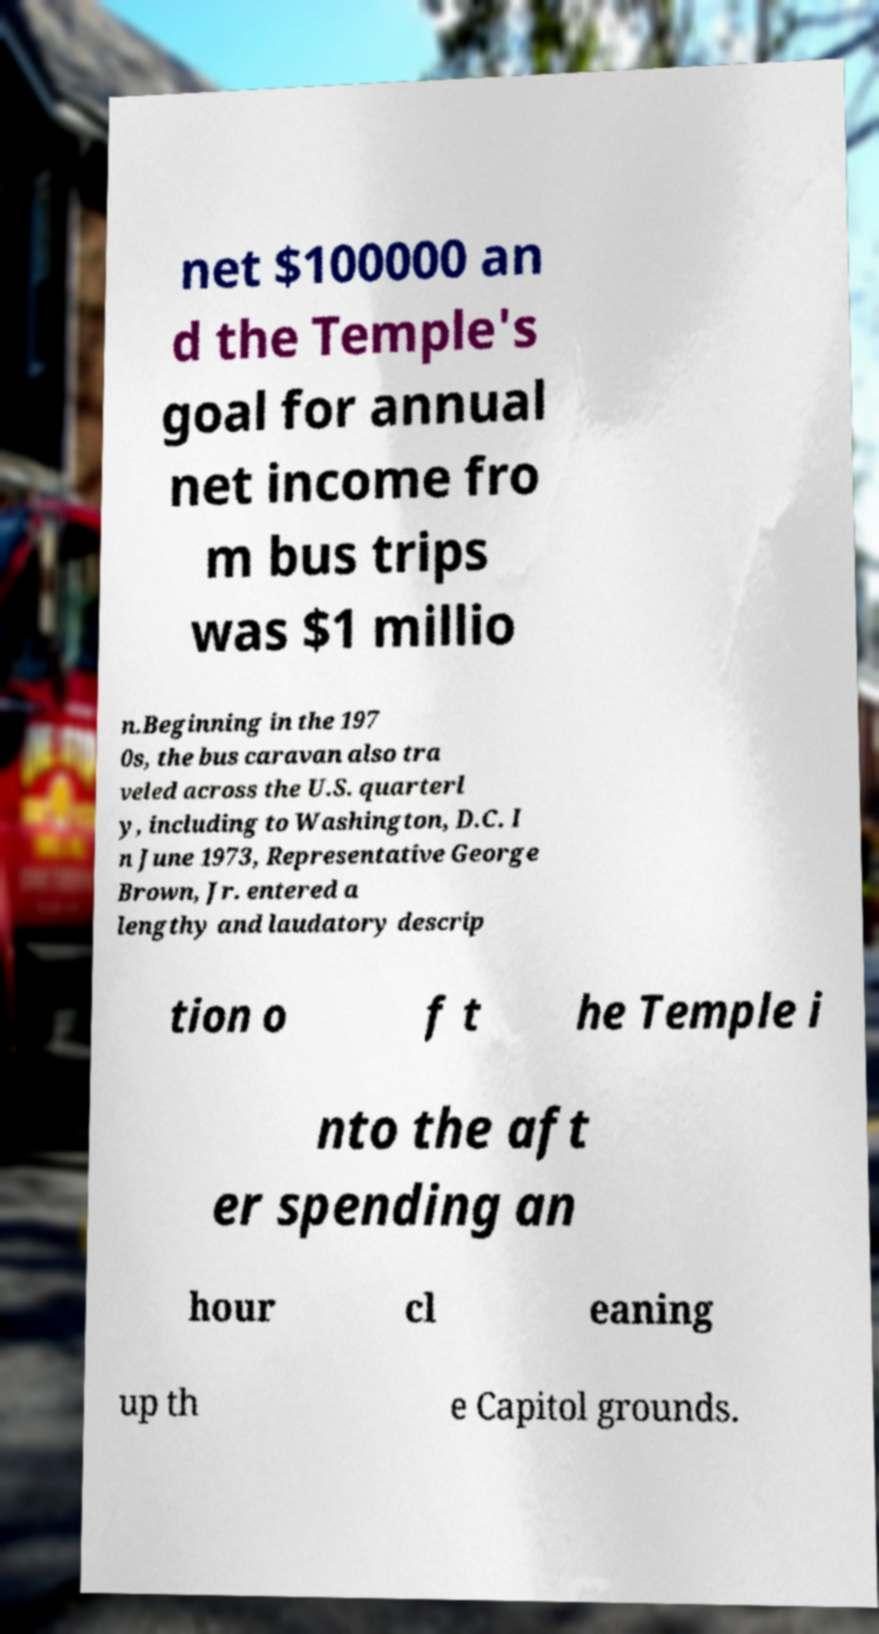Please identify and transcribe the text found in this image. net $100000 an d the Temple's goal for annual net income fro m bus trips was $1 millio n.Beginning in the 197 0s, the bus caravan also tra veled across the U.S. quarterl y, including to Washington, D.C. I n June 1973, Representative George Brown, Jr. entered a lengthy and laudatory descrip tion o f t he Temple i nto the aft er spending an hour cl eaning up th e Capitol grounds. 